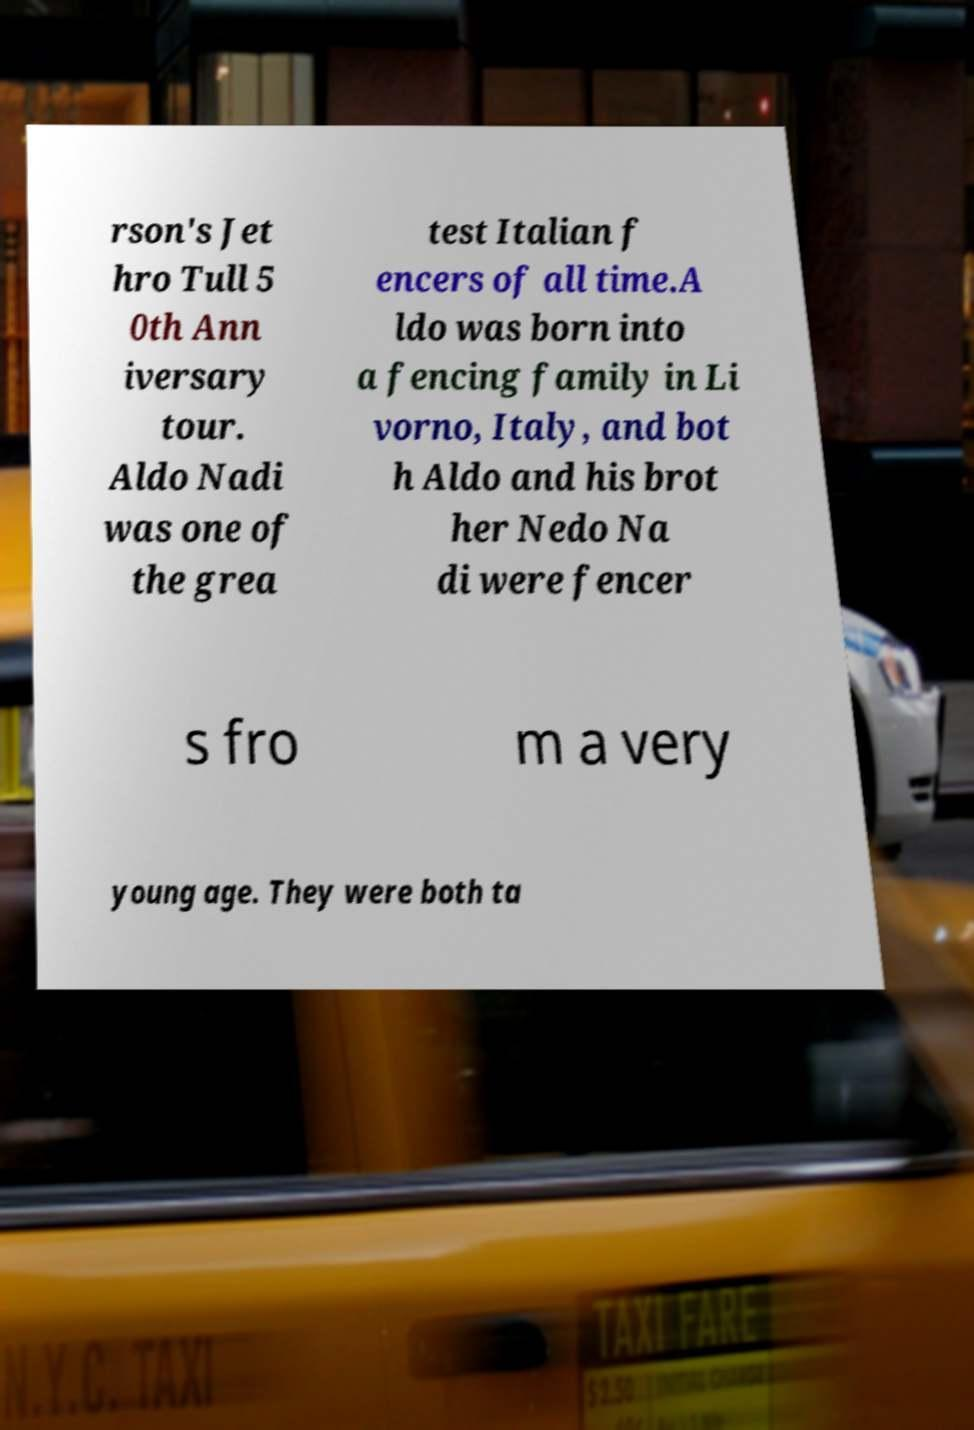Can you accurately transcribe the text from the provided image for me? rson's Jet hro Tull 5 0th Ann iversary tour. Aldo Nadi was one of the grea test Italian f encers of all time.A ldo was born into a fencing family in Li vorno, Italy, and bot h Aldo and his brot her Nedo Na di were fencer s fro m a very young age. They were both ta 